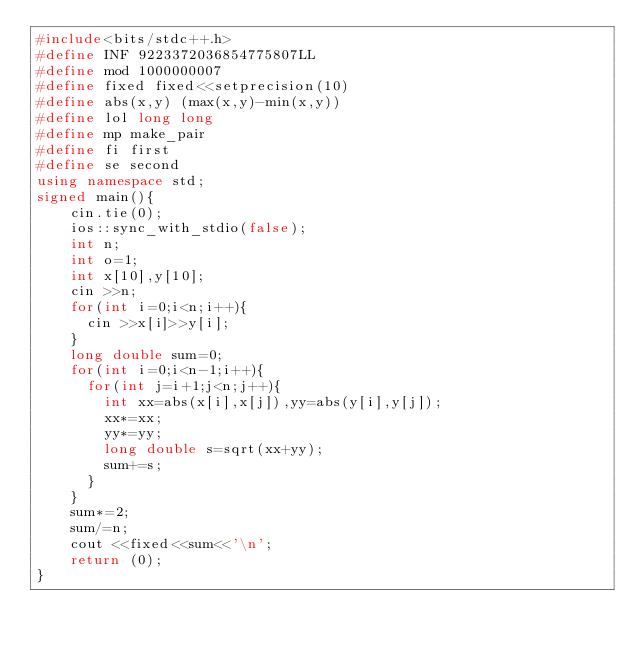Convert code to text. <code><loc_0><loc_0><loc_500><loc_500><_C++_>#include<bits/stdc++.h>
#define INF 9223372036854775807LL
#define mod 1000000007
#define fixed fixed<<setprecision(10)
#define abs(x,y) (max(x,y)-min(x,y))
#define lol long long
#define mp make_pair
#define fi first
#define se second
using namespace std;
signed main(){
    cin.tie(0);
    ios::sync_with_stdio(false);
    int n;
  	int o=1;
  	int x[10],y[10];
  	cin >>n;
  	for(int i=0;i<n;i++){
      cin >>x[i]>>y[i];
    }
  	long double sum=0;
  	for(int i=0;i<n-1;i++){
      for(int j=i+1;j<n;j++){
        int xx=abs(x[i],x[j]),yy=abs(y[i],y[j]);
        xx*=xx;
        yy*=yy;
        long double s=sqrt(xx+yy);
      	sum+=s;
      }
    }
  	sum*=2;
  	sum/=n;
  	cout <<fixed<<sum<<'\n';
    return (0);
}</code> 